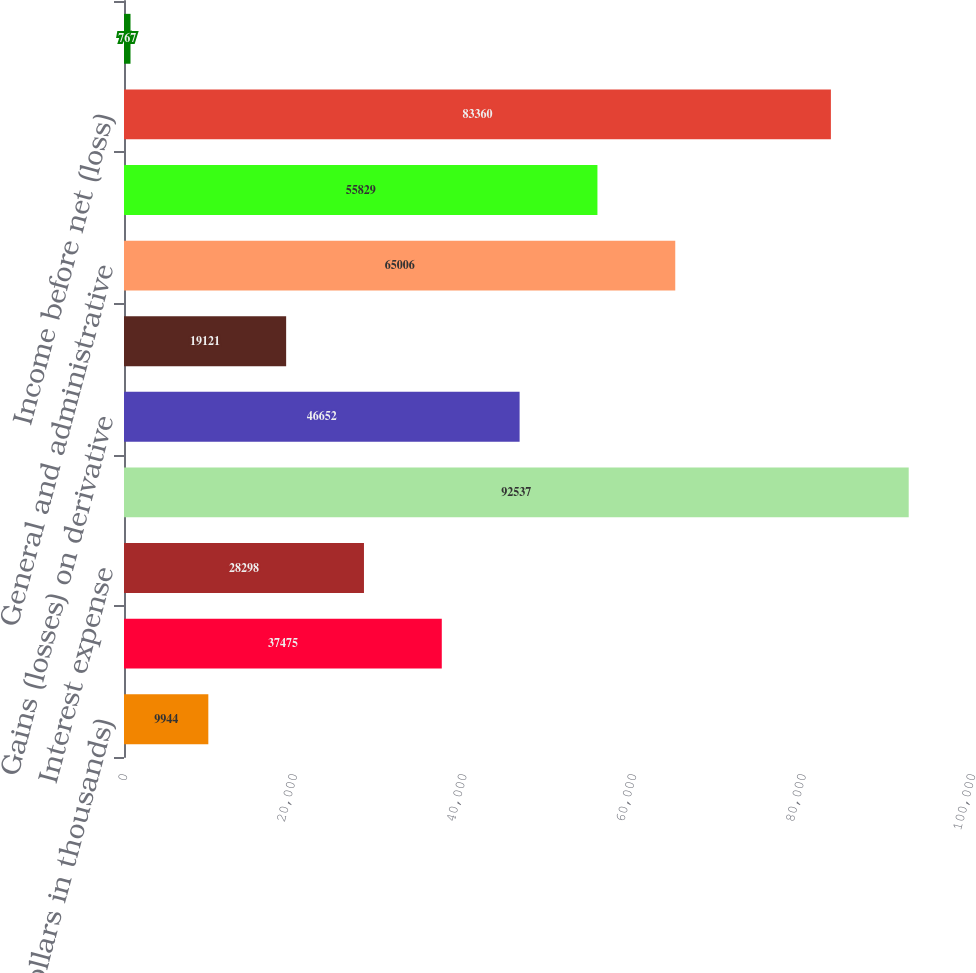Convert chart. <chart><loc_0><loc_0><loc_500><loc_500><bar_chart><fcel>(Dollars in thousands)<fcel>Interest income<fcel>Interest expense<fcel>Dividend income from bank<fcel>Gains (losses) on derivative<fcel>Gains (losses) on investment<fcel>General and administrative<fcel>Income tax benefit<fcel>Income before net (loss)<fcel>Equity in undistributed net<nl><fcel>9944<fcel>37475<fcel>28298<fcel>92537<fcel>46652<fcel>19121<fcel>65006<fcel>55829<fcel>83360<fcel>767<nl></chart> 